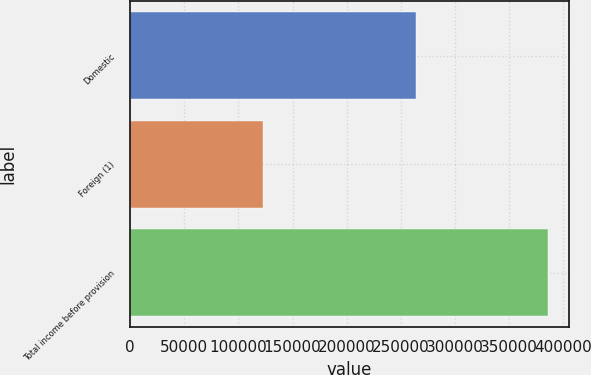<chart> <loc_0><loc_0><loc_500><loc_500><bar_chart><fcel>Domestic<fcel>Foreign (1)<fcel>Total income before provision<nl><fcel>263536<fcel>122402<fcel>385938<nl></chart> 